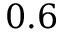Convert formula to latex. <formula><loc_0><loc_0><loc_500><loc_500>0 . 6</formula> 